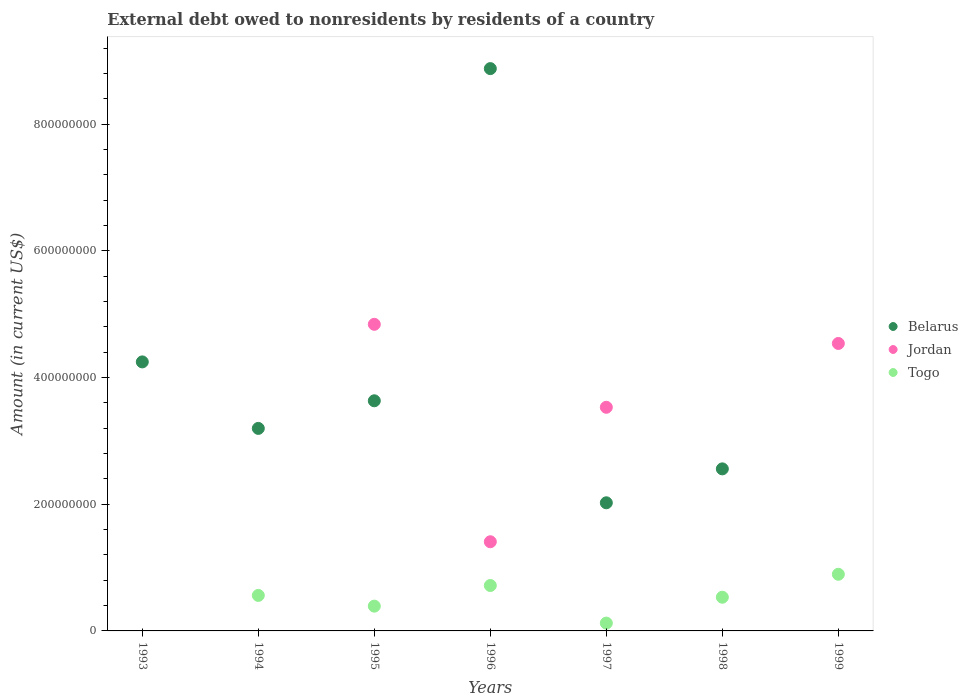How many different coloured dotlines are there?
Provide a succinct answer. 3. What is the external debt owed by residents in Jordan in 1999?
Your answer should be very brief. 4.54e+08. Across all years, what is the maximum external debt owed by residents in Togo?
Provide a succinct answer. 8.94e+07. Across all years, what is the minimum external debt owed by residents in Jordan?
Offer a terse response. 0. What is the total external debt owed by residents in Togo in the graph?
Offer a terse response. 3.22e+08. What is the difference between the external debt owed by residents in Jordan in 1995 and that in 1996?
Make the answer very short. 3.43e+08. What is the difference between the external debt owed by residents in Togo in 1994 and the external debt owed by residents in Belarus in 1995?
Provide a succinct answer. -3.07e+08. What is the average external debt owed by residents in Togo per year?
Your response must be concise. 4.60e+07. In the year 1999, what is the difference between the external debt owed by residents in Togo and external debt owed by residents in Jordan?
Your answer should be very brief. -3.64e+08. What is the ratio of the external debt owed by residents in Belarus in 1995 to that in 1997?
Ensure brevity in your answer.  1.8. What is the difference between the highest and the second highest external debt owed by residents in Togo?
Keep it short and to the point. 1.77e+07. What is the difference between the highest and the lowest external debt owed by residents in Belarus?
Keep it short and to the point. 8.88e+08. In how many years, is the external debt owed by residents in Togo greater than the average external debt owed by residents in Togo taken over all years?
Provide a succinct answer. 4. Is it the case that in every year, the sum of the external debt owed by residents in Togo and external debt owed by residents in Jordan  is greater than the external debt owed by residents in Belarus?
Offer a terse response. No. Is the external debt owed by residents in Togo strictly less than the external debt owed by residents in Belarus over the years?
Make the answer very short. No. How many dotlines are there?
Offer a very short reply. 3. How many years are there in the graph?
Give a very brief answer. 7. Does the graph contain any zero values?
Provide a succinct answer. Yes. Does the graph contain grids?
Make the answer very short. No. How many legend labels are there?
Your answer should be compact. 3. What is the title of the graph?
Provide a short and direct response. External debt owed to nonresidents by residents of a country. What is the label or title of the Y-axis?
Offer a terse response. Amount (in current US$). What is the Amount (in current US$) of Belarus in 1993?
Provide a short and direct response. 4.25e+08. What is the Amount (in current US$) in Belarus in 1994?
Your response must be concise. 3.20e+08. What is the Amount (in current US$) of Togo in 1994?
Keep it short and to the point. 5.61e+07. What is the Amount (in current US$) of Belarus in 1995?
Your answer should be compact. 3.63e+08. What is the Amount (in current US$) of Jordan in 1995?
Ensure brevity in your answer.  4.84e+08. What is the Amount (in current US$) in Togo in 1995?
Your answer should be compact. 3.91e+07. What is the Amount (in current US$) in Belarus in 1996?
Your answer should be very brief. 8.88e+08. What is the Amount (in current US$) of Jordan in 1996?
Make the answer very short. 1.41e+08. What is the Amount (in current US$) in Togo in 1996?
Your response must be concise. 7.17e+07. What is the Amount (in current US$) of Belarus in 1997?
Provide a short and direct response. 2.02e+08. What is the Amount (in current US$) in Jordan in 1997?
Ensure brevity in your answer.  3.53e+08. What is the Amount (in current US$) in Togo in 1997?
Your answer should be very brief. 1.23e+07. What is the Amount (in current US$) of Belarus in 1998?
Keep it short and to the point. 2.56e+08. What is the Amount (in current US$) of Jordan in 1998?
Your answer should be compact. 0. What is the Amount (in current US$) of Togo in 1998?
Make the answer very short. 5.32e+07. What is the Amount (in current US$) in Jordan in 1999?
Offer a terse response. 4.54e+08. What is the Amount (in current US$) of Togo in 1999?
Your answer should be compact. 8.94e+07. Across all years, what is the maximum Amount (in current US$) of Belarus?
Provide a short and direct response. 8.88e+08. Across all years, what is the maximum Amount (in current US$) in Jordan?
Ensure brevity in your answer.  4.84e+08. Across all years, what is the maximum Amount (in current US$) in Togo?
Provide a succinct answer. 8.94e+07. Across all years, what is the minimum Amount (in current US$) of Jordan?
Your response must be concise. 0. What is the total Amount (in current US$) of Belarus in the graph?
Ensure brevity in your answer.  2.45e+09. What is the total Amount (in current US$) in Jordan in the graph?
Ensure brevity in your answer.  1.43e+09. What is the total Amount (in current US$) of Togo in the graph?
Give a very brief answer. 3.22e+08. What is the difference between the Amount (in current US$) of Belarus in 1993 and that in 1994?
Your response must be concise. 1.05e+08. What is the difference between the Amount (in current US$) in Belarus in 1993 and that in 1995?
Provide a short and direct response. 6.14e+07. What is the difference between the Amount (in current US$) of Belarus in 1993 and that in 1996?
Your response must be concise. -4.63e+08. What is the difference between the Amount (in current US$) of Belarus in 1993 and that in 1997?
Give a very brief answer. 2.22e+08. What is the difference between the Amount (in current US$) of Belarus in 1993 and that in 1998?
Your answer should be very brief. 1.69e+08. What is the difference between the Amount (in current US$) in Belarus in 1994 and that in 1995?
Your answer should be compact. -4.36e+07. What is the difference between the Amount (in current US$) in Togo in 1994 and that in 1995?
Give a very brief answer. 1.69e+07. What is the difference between the Amount (in current US$) in Belarus in 1994 and that in 1996?
Make the answer very short. -5.68e+08. What is the difference between the Amount (in current US$) in Togo in 1994 and that in 1996?
Provide a succinct answer. -1.56e+07. What is the difference between the Amount (in current US$) in Belarus in 1994 and that in 1997?
Ensure brevity in your answer.  1.17e+08. What is the difference between the Amount (in current US$) of Togo in 1994 and that in 1997?
Make the answer very short. 4.37e+07. What is the difference between the Amount (in current US$) in Belarus in 1994 and that in 1998?
Keep it short and to the point. 6.39e+07. What is the difference between the Amount (in current US$) in Togo in 1994 and that in 1998?
Your response must be concise. 2.86e+06. What is the difference between the Amount (in current US$) of Togo in 1994 and that in 1999?
Your response must be concise. -3.34e+07. What is the difference between the Amount (in current US$) of Belarus in 1995 and that in 1996?
Your response must be concise. -5.24e+08. What is the difference between the Amount (in current US$) in Jordan in 1995 and that in 1996?
Offer a terse response. 3.43e+08. What is the difference between the Amount (in current US$) of Togo in 1995 and that in 1996?
Your answer should be compact. -3.26e+07. What is the difference between the Amount (in current US$) of Belarus in 1995 and that in 1997?
Offer a very short reply. 1.61e+08. What is the difference between the Amount (in current US$) of Jordan in 1995 and that in 1997?
Your answer should be very brief. 1.31e+08. What is the difference between the Amount (in current US$) of Togo in 1995 and that in 1997?
Offer a terse response. 2.68e+07. What is the difference between the Amount (in current US$) in Belarus in 1995 and that in 1998?
Offer a very short reply. 1.08e+08. What is the difference between the Amount (in current US$) in Togo in 1995 and that in 1998?
Give a very brief answer. -1.41e+07. What is the difference between the Amount (in current US$) in Jordan in 1995 and that in 1999?
Offer a terse response. 3.02e+07. What is the difference between the Amount (in current US$) of Togo in 1995 and that in 1999?
Provide a succinct answer. -5.03e+07. What is the difference between the Amount (in current US$) of Belarus in 1996 and that in 1997?
Make the answer very short. 6.86e+08. What is the difference between the Amount (in current US$) in Jordan in 1996 and that in 1997?
Give a very brief answer. -2.12e+08. What is the difference between the Amount (in current US$) in Togo in 1996 and that in 1997?
Your answer should be compact. 5.94e+07. What is the difference between the Amount (in current US$) of Belarus in 1996 and that in 1998?
Keep it short and to the point. 6.32e+08. What is the difference between the Amount (in current US$) in Togo in 1996 and that in 1998?
Ensure brevity in your answer.  1.85e+07. What is the difference between the Amount (in current US$) in Jordan in 1996 and that in 1999?
Give a very brief answer. -3.13e+08. What is the difference between the Amount (in current US$) of Togo in 1996 and that in 1999?
Offer a very short reply. -1.77e+07. What is the difference between the Amount (in current US$) in Belarus in 1997 and that in 1998?
Give a very brief answer. -5.36e+07. What is the difference between the Amount (in current US$) of Togo in 1997 and that in 1998?
Your response must be concise. -4.09e+07. What is the difference between the Amount (in current US$) of Jordan in 1997 and that in 1999?
Your answer should be compact. -1.01e+08. What is the difference between the Amount (in current US$) of Togo in 1997 and that in 1999?
Your answer should be very brief. -7.71e+07. What is the difference between the Amount (in current US$) in Togo in 1998 and that in 1999?
Your response must be concise. -3.62e+07. What is the difference between the Amount (in current US$) of Belarus in 1993 and the Amount (in current US$) of Togo in 1994?
Offer a very short reply. 3.69e+08. What is the difference between the Amount (in current US$) of Belarus in 1993 and the Amount (in current US$) of Jordan in 1995?
Offer a very short reply. -5.93e+07. What is the difference between the Amount (in current US$) in Belarus in 1993 and the Amount (in current US$) in Togo in 1995?
Provide a succinct answer. 3.86e+08. What is the difference between the Amount (in current US$) in Belarus in 1993 and the Amount (in current US$) in Jordan in 1996?
Keep it short and to the point. 2.84e+08. What is the difference between the Amount (in current US$) of Belarus in 1993 and the Amount (in current US$) of Togo in 1996?
Provide a succinct answer. 3.53e+08. What is the difference between the Amount (in current US$) in Belarus in 1993 and the Amount (in current US$) in Jordan in 1997?
Your response must be concise. 7.17e+07. What is the difference between the Amount (in current US$) in Belarus in 1993 and the Amount (in current US$) in Togo in 1997?
Make the answer very short. 4.12e+08. What is the difference between the Amount (in current US$) in Belarus in 1993 and the Amount (in current US$) in Togo in 1998?
Give a very brief answer. 3.72e+08. What is the difference between the Amount (in current US$) in Belarus in 1993 and the Amount (in current US$) in Jordan in 1999?
Your answer should be compact. -2.91e+07. What is the difference between the Amount (in current US$) in Belarus in 1993 and the Amount (in current US$) in Togo in 1999?
Offer a very short reply. 3.35e+08. What is the difference between the Amount (in current US$) in Belarus in 1994 and the Amount (in current US$) in Jordan in 1995?
Offer a very short reply. -1.64e+08. What is the difference between the Amount (in current US$) of Belarus in 1994 and the Amount (in current US$) of Togo in 1995?
Provide a short and direct response. 2.81e+08. What is the difference between the Amount (in current US$) of Belarus in 1994 and the Amount (in current US$) of Jordan in 1996?
Keep it short and to the point. 1.79e+08. What is the difference between the Amount (in current US$) in Belarus in 1994 and the Amount (in current US$) in Togo in 1996?
Your answer should be very brief. 2.48e+08. What is the difference between the Amount (in current US$) of Belarus in 1994 and the Amount (in current US$) of Jordan in 1997?
Ensure brevity in your answer.  -3.33e+07. What is the difference between the Amount (in current US$) of Belarus in 1994 and the Amount (in current US$) of Togo in 1997?
Your answer should be very brief. 3.07e+08. What is the difference between the Amount (in current US$) in Belarus in 1994 and the Amount (in current US$) in Togo in 1998?
Ensure brevity in your answer.  2.67e+08. What is the difference between the Amount (in current US$) of Belarus in 1994 and the Amount (in current US$) of Jordan in 1999?
Your answer should be very brief. -1.34e+08. What is the difference between the Amount (in current US$) in Belarus in 1994 and the Amount (in current US$) in Togo in 1999?
Make the answer very short. 2.30e+08. What is the difference between the Amount (in current US$) of Belarus in 1995 and the Amount (in current US$) of Jordan in 1996?
Your response must be concise. 2.23e+08. What is the difference between the Amount (in current US$) of Belarus in 1995 and the Amount (in current US$) of Togo in 1996?
Offer a terse response. 2.92e+08. What is the difference between the Amount (in current US$) in Jordan in 1995 and the Amount (in current US$) in Togo in 1996?
Keep it short and to the point. 4.12e+08. What is the difference between the Amount (in current US$) of Belarus in 1995 and the Amount (in current US$) of Jordan in 1997?
Your answer should be very brief. 1.03e+07. What is the difference between the Amount (in current US$) of Belarus in 1995 and the Amount (in current US$) of Togo in 1997?
Your answer should be very brief. 3.51e+08. What is the difference between the Amount (in current US$) of Jordan in 1995 and the Amount (in current US$) of Togo in 1997?
Keep it short and to the point. 4.72e+08. What is the difference between the Amount (in current US$) of Belarus in 1995 and the Amount (in current US$) of Togo in 1998?
Give a very brief answer. 3.10e+08. What is the difference between the Amount (in current US$) in Jordan in 1995 and the Amount (in current US$) in Togo in 1998?
Your response must be concise. 4.31e+08. What is the difference between the Amount (in current US$) in Belarus in 1995 and the Amount (in current US$) in Jordan in 1999?
Keep it short and to the point. -9.05e+07. What is the difference between the Amount (in current US$) in Belarus in 1995 and the Amount (in current US$) in Togo in 1999?
Your answer should be compact. 2.74e+08. What is the difference between the Amount (in current US$) of Jordan in 1995 and the Amount (in current US$) of Togo in 1999?
Provide a succinct answer. 3.95e+08. What is the difference between the Amount (in current US$) in Belarus in 1996 and the Amount (in current US$) in Jordan in 1997?
Offer a very short reply. 5.35e+08. What is the difference between the Amount (in current US$) of Belarus in 1996 and the Amount (in current US$) of Togo in 1997?
Ensure brevity in your answer.  8.75e+08. What is the difference between the Amount (in current US$) in Jordan in 1996 and the Amount (in current US$) in Togo in 1997?
Offer a very short reply. 1.28e+08. What is the difference between the Amount (in current US$) of Belarus in 1996 and the Amount (in current US$) of Togo in 1998?
Provide a short and direct response. 8.35e+08. What is the difference between the Amount (in current US$) in Jordan in 1996 and the Amount (in current US$) in Togo in 1998?
Offer a terse response. 8.76e+07. What is the difference between the Amount (in current US$) of Belarus in 1996 and the Amount (in current US$) of Jordan in 1999?
Your answer should be compact. 4.34e+08. What is the difference between the Amount (in current US$) of Belarus in 1996 and the Amount (in current US$) of Togo in 1999?
Offer a terse response. 7.98e+08. What is the difference between the Amount (in current US$) in Jordan in 1996 and the Amount (in current US$) in Togo in 1999?
Your response must be concise. 5.13e+07. What is the difference between the Amount (in current US$) in Belarus in 1997 and the Amount (in current US$) in Togo in 1998?
Make the answer very short. 1.49e+08. What is the difference between the Amount (in current US$) of Jordan in 1997 and the Amount (in current US$) of Togo in 1998?
Offer a terse response. 3.00e+08. What is the difference between the Amount (in current US$) of Belarus in 1997 and the Amount (in current US$) of Jordan in 1999?
Ensure brevity in your answer.  -2.52e+08. What is the difference between the Amount (in current US$) of Belarus in 1997 and the Amount (in current US$) of Togo in 1999?
Provide a succinct answer. 1.13e+08. What is the difference between the Amount (in current US$) of Jordan in 1997 and the Amount (in current US$) of Togo in 1999?
Provide a short and direct response. 2.64e+08. What is the difference between the Amount (in current US$) of Belarus in 1998 and the Amount (in current US$) of Jordan in 1999?
Offer a terse response. -1.98e+08. What is the difference between the Amount (in current US$) in Belarus in 1998 and the Amount (in current US$) in Togo in 1999?
Keep it short and to the point. 1.66e+08. What is the average Amount (in current US$) of Belarus per year?
Provide a succinct answer. 3.51e+08. What is the average Amount (in current US$) in Jordan per year?
Offer a terse response. 2.05e+08. What is the average Amount (in current US$) of Togo per year?
Provide a short and direct response. 4.60e+07. In the year 1994, what is the difference between the Amount (in current US$) in Belarus and Amount (in current US$) in Togo?
Provide a short and direct response. 2.64e+08. In the year 1995, what is the difference between the Amount (in current US$) in Belarus and Amount (in current US$) in Jordan?
Provide a short and direct response. -1.21e+08. In the year 1995, what is the difference between the Amount (in current US$) in Belarus and Amount (in current US$) in Togo?
Make the answer very short. 3.24e+08. In the year 1995, what is the difference between the Amount (in current US$) of Jordan and Amount (in current US$) of Togo?
Provide a succinct answer. 4.45e+08. In the year 1996, what is the difference between the Amount (in current US$) of Belarus and Amount (in current US$) of Jordan?
Your answer should be compact. 7.47e+08. In the year 1996, what is the difference between the Amount (in current US$) in Belarus and Amount (in current US$) in Togo?
Give a very brief answer. 8.16e+08. In the year 1996, what is the difference between the Amount (in current US$) of Jordan and Amount (in current US$) of Togo?
Ensure brevity in your answer.  6.91e+07. In the year 1997, what is the difference between the Amount (in current US$) of Belarus and Amount (in current US$) of Jordan?
Make the answer very short. -1.51e+08. In the year 1997, what is the difference between the Amount (in current US$) in Belarus and Amount (in current US$) in Togo?
Ensure brevity in your answer.  1.90e+08. In the year 1997, what is the difference between the Amount (in current US$) of Jordan and Amount (in current US$) of Togo?
Give a very brief answer. 3.41e+08. In the year 1998, what is the difference between the Amount (in current US$) of Belarus and Amount (in current US$) of Togo?
Your response must be concise. 2.03e+08. In the year 1999, what is the difference between the Amount (in current US$) of Jordan and Amount (in current US$) of Togo?
Offer a very short reply. 3.64e+08. What is the ratio of the Amount (in current US$) of Belarus in 1993 to that in 1994?
Offer a terse response. 1.33. What is the ratio of the Amount (in current US$) in Belarus in 1993 to that in 1995?
Ensure brevity in your answer.  1.17. What is the ratio of the Amount (in current US$) of Belarus in 1993 to that in 1996?
Your answer should be very brief. 0.48. What is the ratio of the Amount (in current US$) in Belarus in 1993 to that in 1997?
Keep it short and to the point. 2.1. What is the ratio of the Amount (in current US$) in Belarus in 1993 to that in 1998?
Provide a short and direct response. 1.66. What is the ratio of the Amount (in current US$) of Belarus in 1994 to that in 1995?
Provide a succinct answer. 0.88. What is the ratio of the Amount (in current US$) in Togo in 1994 to that in 1995?
Ensure brevity in your answer.  1.43. What is the ratio of the Amount (in current US$) in Belarus in 1994 to that in 1996?
Ensure brevity in your answer.  0.36. What is the ratio of the Amount (in current US$) in Togo in 1994 to that in 1996?
Keep it short and to the point. 0.78. What is the ratio of the Amount (in current US$) in Belarus in 1994 to that in 1997?
Offer a very short reply. 1.58. What is the ratio of the Amount (in current US$) of Togo in 1994 to that in 1997?
Provide a short and direct response. 4.54. What is the ratio of the Amount (in current US$) of Belarus in 1994 to that in 1998?
Provide a succinct answer. 1.25. What is the ratio of the Amount (in current US$) of Togo in 1994 to that in 1998?
Offer a terse response. 1.05. What is the ratio of the Amount (in current US$) in Togo in 1994 to that in 1999?
Offer a very short reply. 0.63. What is the ratio of the Amount (in current US$) of Belarus in 1995 to that in 1996?
Provide a short and direct response. 0.41. What is the ratio of the Amount (in current US$) of Jordan in 1995 to that in 1996?
Provide a succinct answer. 3.44. What is the ratio of the Amount (in current US$) of Togo in 1995 to that in 1996?
Make the answer very short. 0.55. What is the ratio of the Amount (in current US$) in Belarus in 1995 to that in 1997?
Your answer should be very brief. 1.8. What is the ratio of the Amount (in current US$) of Jordan in 1995 to that in 1997?
Offer a very short reply. 1.37. What is the ratio of the Amount (in current US$) of Togo in 1995 to that in 1997?
Provide a short and direct response. 3.17. What is the ratio of the Amount (in current US$) of Belarus in 1995 to that in 1998?
Offer a terse response. 1.42. What is the ratio of the Amount (in current US$) in Togo in 1995 to that in 1998?
Provide a succinct answer. 0.74. What is the ratio of the Amount (in current US$) in Jordan in 1995 to that in 1999?
Ensure brevity in your answer.  1.07. What is the ratio of the Amount (in current US$) in Togo in 1995 to that in 1999?
Provide a succinct answer. 0.44. What is the ratio of the Amount (in current US$) in Belarus in 1996 to that in 1997?
Provide a short and direct response. 4.39. What is the ratio of the Amount (in current US$) of Jordan in 1996 to that in 1997?
Your response must be concise. 0.4. What is the ratio of the Amount (in current US$) of Togo in 1996 to that in 1997?
Provide a short and direct response. 5.81. What is the ratio of the Amount (in current US$) of Belarus in 1996 to that in 1998?
Make the answer very short. 3.47. What is the ratio of the Amount (in current US$) in Togo in 1996 to that in 1998?
Give a very brief answer. 1.35. What is the ratio of the Amount (in current US$) of Jordan in 1996 to that in 1999?
Your answer should be very brief. 0.31. What is the ratio of the Amount (in current US$) of Togo in 1996 to that in 1999?
Keep it short and to the point. 0.8. What is the ratio of the Amount (in current US$) of Belarus in 1997 to that in 1998?
Your response must be concise. 0.79. What is the ratio of the Amount (in current US$) of Togo in 1997 to that in 1998?
Ensure brevity in your answer.  0.23. What is the ratio of the Amount (in current US$) of Jordan in 1997 to that in 1999?
Make the answer very short. 0.78. What is the ratio of the Amount (in current US$) in Togo in 1997 to that in 1999?
Offer a terse response. 0.14. What is the ratio of the Amount (in current US$) of Togo in 1998 to that in 1999?
Offer a terse response. 0.59. What is the difference between the highest and the second highest Amount (in current US$) of Belarus?
Keep it short and to the point. 4.63e+08. What is the difference between the highest and the second highest Amount (in current US$) in Jordan?
Your answer should be compact. 3.02e+07. What is the difference between the highest and the second highest Amount (in current US$) in Togo?
Provide a succinct answer. 1.77e+07. What is the difference between the highest and the lowest Amount (in current US$) in Belarus?
Keep it short and to the point. 8.88e+08. What is the difference between the highest and the lowest Amount (in current US$) of Jordan?
Your response must be concise. 4.84e+08. What is the difference between the highest and the lowest Amount (in current US$) of Togo?
Make the answer very short. 8.94e+07. 